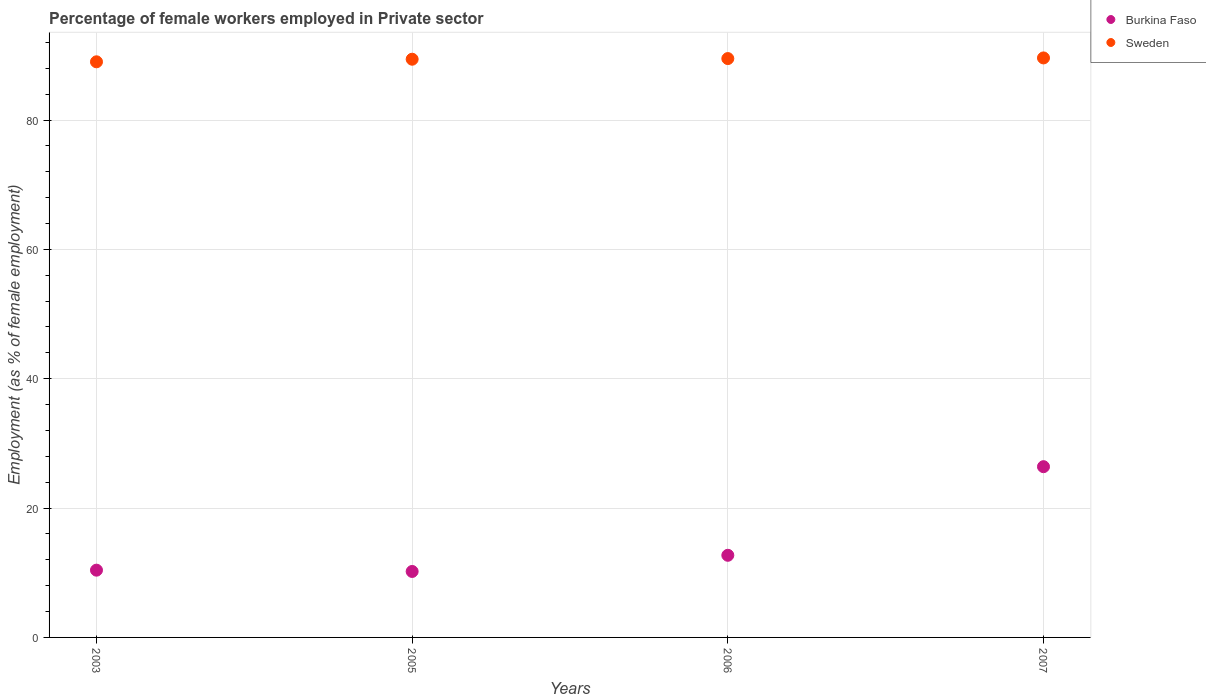How many different coloured dotlines are there?
Your response must be concise. 2. What is the percentage of females employed in Private sector in Sweden in 2007?
Make the answer very short. 89.6. Across all years, what is the maximum percentage of females employed in Private sector in Sweden?
Offer a terse response. 89.6. Across all years, what is the minimum percentage of females employed in Private sector in Burkina Faso?
Ensure brevity in your answer.  10.2. In which year was the percentage of females employed in Private sector in Sweden minimum?
Offer a terse response. 2003. What is the total percentage of females employed in Private sector in Sweden in the graph?
Keep it short and to the point. 357.5. What is the difference between the percentage of females employed in Private sector in Sweden in 2003 and that in 2005?
Provide a succinct answer. -0.4. What is the difference between the percentage of females employed in Private sector in Sweden in 2006 and the percentage of females employed in Private sector in Burkina Faso in 2003?
Your answer should be compact. 79.1. What is the average percentage of females employed in Private sector in Burkina Faso per year?
Keep it short and to the point. 14.92. In the year 2005, what is the difference between the percentage of females employed in Private sector in Burkina Faso and percentage of females employed in Private sector in Sweden?
Provide a short and direct response. -79.2. In how many years, is the percentage of females employed in Private sector in Sweden greater than 44 %?
Offer a terse response. 4. What is the ratio of the percentage of females employed in Private sector in Burkina Faso in 2005 to that in 2006?
Your answer should be very brief. 0.8. Is the percentage of females employed in Private sector in Sweden in 2005 less than that in 2006?
Keep it short and to the point. Yes. Is the difference between the percentage of females employed in Private sector in Burkina Faso in 2003 and 2005 greater than the difference between the percentage of females employed in Private sector in Sweden in 2003 and 2005?
Your answer should be compact. Yes. What is the difference between the highest and the second highest percentage of females employed in Private sector in Sweden?
Your answer should be compact. 0.1. What is the difference between the highest and the lowest percentage of females employed in Private sector in Burkina Faso?
Your answer should be compact. 16.2. In how many years, is the percentage of females employed in Private sector in Sweden greater than the average percentage of females employed in Private sector in Sweden taken over all years?
Offer a terse response. 3. Is the sum of the percentage of females employed in Private sector in Burkina Faso in 2005 and 2007 greater than the maximum percentage of females employed in Private sector in Sweden across all years?
Provide a short and direct response. No. Does the percentage of females employed in Private sector in Burkina Faso monotonically increase over the years?
Make the answer very short. No. Is the percentage of females employed in Private sector in Sweden strictly greater than the percentage of females employed in Private sector in Burkina Faso over the years?
Ensure brevity in your answer.  Yes. How many years are there in the graph?
Your answer should be very brief. 4. What is the difference between two consecutive major ticks on the Y-axis?
Your response must be concise. 20. Are the values on the major ticks of Y-axis written in scientific E-notation?
Ensure brevity in your answer.  No. Does the graph contain grids?
Provide a succinct answer. Yes. Where does the legend appear in the graph?
Your response must be concise. Top right. How many legend labels are there?
Offer a terse response. 2. How are the legend labels stacked?
Offer a terse response. Vertical. What is the title of the graph?
Your answer should be compact. Percentage of female workers employed in Private sector. What is the label or title of the X-axis?
Ensure brevity in your answer.  Years. What is the label or title of the Y-axis?
Your answer should be very brief. Employment (as % of female employment). What is the Employment (as % of female employment) in Burkina Faso in 2003?
Ensure brevity in your answer.  10.4. What is the Employment (as % of female employment) of Sweden in 2003?
Provide a short and direct response. 89. What is the Employment (as % of female employment) in Burkina Faso in 2005?
Keep it short and to the point. 10.2. What is the Employment (as % of female employment) in Sweden in 2005?
Keep it short and to the point. 89.4. What is the Employment (as % of female employment) of Burkina Faso in 2006?
Your answer should be very brief. 12.7. What is the Employment (as % of female employment) of Sweden in 2006?
Offer a very short reply. 89.5. What is the Employment (as % of female employment) in Burkina Faso in 2007?
Your answer should be compact. 26.4. What is the Employment (as % of female employment) of Sweden in 2007?
Your response must be concise. 89.6. Across all years, what is the maximum Employment (as % of female employment) in Burkina Faso?
Ensure brevity in your answer.  26.4. Across all years, what is the maximum Employment (as % of female employment) in Sweden?
Keep it short and to the point. 89.6. Across all years, what is the minimum Employment (as % of female employment) of Burkina Faso?
Make the answer very short. 10.2. Across all years, what is the minimum Employment (as % of female employment) of Sweden?
Your response must be concise. 89. What is the total Employment (as % of female employment) in Burkina Faso in the graph?
Your answer should be very brief. 59.7. What is the total Employment (as % of female employment) in Sweden in the graph?
Offer a very short reply. 357.5. What is the difference between the Employment (as % of female employment) in Sweden in 2003 and that in 2005?
Provide a short and direct response. -0.4. What is the difference between the Employment (as % of female employment) of Burkina Faso in 2003 and that in 2006?
Offer a terse response. -2.3. What is the difference between the Employment (as % of female employment) of Sweden in 2003 and that in 2006?
Offer a terse response. -0.5. What is the difference between the Employment (as % of female employment) of Burkina Faso in 2005 and that in 2006?
Give a very brief answer. -2.5. What is the difference between the Employment (as % of female employment) in Burkina Faso in 2005 and that in 2007?
Ensure brevity in your answer.  -16.2. What is the difference between the Employment (as % of female employment) in Sweden in 2005 and that in 2007?
Keep it short and to the point. -0.2. What is the difference between the Employment (as % of female employment) in Burkina Faso in 2006 and that in 2007?
Provide a short and direct response. -13.7. What is the difference between the Employment (as % of female employment) of Sweden in 2006 and that in 2007?
Offer a very short reply. -0.1. What is the difference between the Employment (as % of female employment) of Burkina Faso in 2003 and the Employment (as % of female employment) of Sweden in 2005?
Provide a succinct answer. -79. What is the difference between the Employment (as % of female employment) of Burkina Faso in 2003 and the Employment (as % of female employment) of Sweden in 2006?
Your response must be concise. -79.1. What is the difference between the Employment (as % of female employment) of Burkina Faso in 2003 and the Employment (as % of female employment) of Sweden in 2007?
Offer a terse response. -79.2. What is the difference between the Employment (as % of female employment) in Burkina Faso in 2005 and the Employment (as % of female employment) in Sweden in 2006?
Your answer should be very brief. -79.3. What is the difference between the Employment (as % of female employment) in Burkina Faso in 2005 and the Employment (as % of female employment) in Sweden in 2007?
Your response must be concise. -79.4. What is the difference between the Employment (as % of female employment) in Burkina Faso in 2006 and the Employment (as % of female employment) in Sweden in 2007?
Your answer should be compact. -76.9. What is the average Employment (as % of female employment) of Burkina Faso per year?
Your response must be concise. 14.93. What is the average Employment (as % of female employment) of Sweden per year?
Your response must be concise. 89.38. In the year 2003, what is the difference between the Employment (as % of female employment) of Burkina Faso and Employment (as % of female employment) of Sweden?
Give a very brief answer. -78.6. In the year 2005, what is the difference between the Employment (as % of female employment) in Burkina Faso and Employment (as % of female employment) in Sweden?
Provide a short and direct response. -79.2. In the year 2006, what is the difference between the Employment (as % of female employment) in Burkina Faso and Employment (as % of female employment) in Sweden?
Your response must be concise. -76.8. In the year 2007, what is the difference between the Employment (as % of female employment) in Burkina Faso and Employment (as % of female employment) in Sweden?
Give a very brief answer. -63.2. What is the ratio of the Employment (as % of female employment) of Burkina Faso in 2003 to that in 2005?
Offer a very short reply. 1.02. What is the ratio of the Employment (as % of female employment) of Sweden in 2003 to that in 2005?
Make the answer very short. 1. What is the ratio of the Employment (as % of female employment) of Burkina Faso in 2003 to that in 2006?
Your answer should be very brief. 0.82. What is the ratio of the Employment (as % of female employment) in Sweden in 2003 to that in 2006?
Your response must be concise. 0.99. What is the ratio of the Employment (as % of female employment) of Burkina Faso in 2003 to that in 2007?
Make the answer very short. 0.39. What is the ratio of the Employment (as % of female employment) in Sweden in 2003 to that in 2007?
Your answer should be very brief. 0.99. What is the ratio of the Employment (as % of female employment) of Burkina Faso in 2005 to that in 2006?
Your answer should be compact. 0.8. What is the ratio of the Employment (as % of female employment) of Burkina Faso in 2005 to that in 2007?
Ensure brevity in your answer.  0.39. What is the ratio of the Employment (as % of female employment) in Sweden in 2005 to that in 2007?
Offer a very short reply. 1. What is the ratio of the Employment (as % of female employment) in Burkina Faso in 2006 to that in 2007?
Your response must be concise. 0.48. What is the ratio of the Employment (as % of female employment) in Sweden in 2006 to that in 2007?
Make the answer very short. 1. 